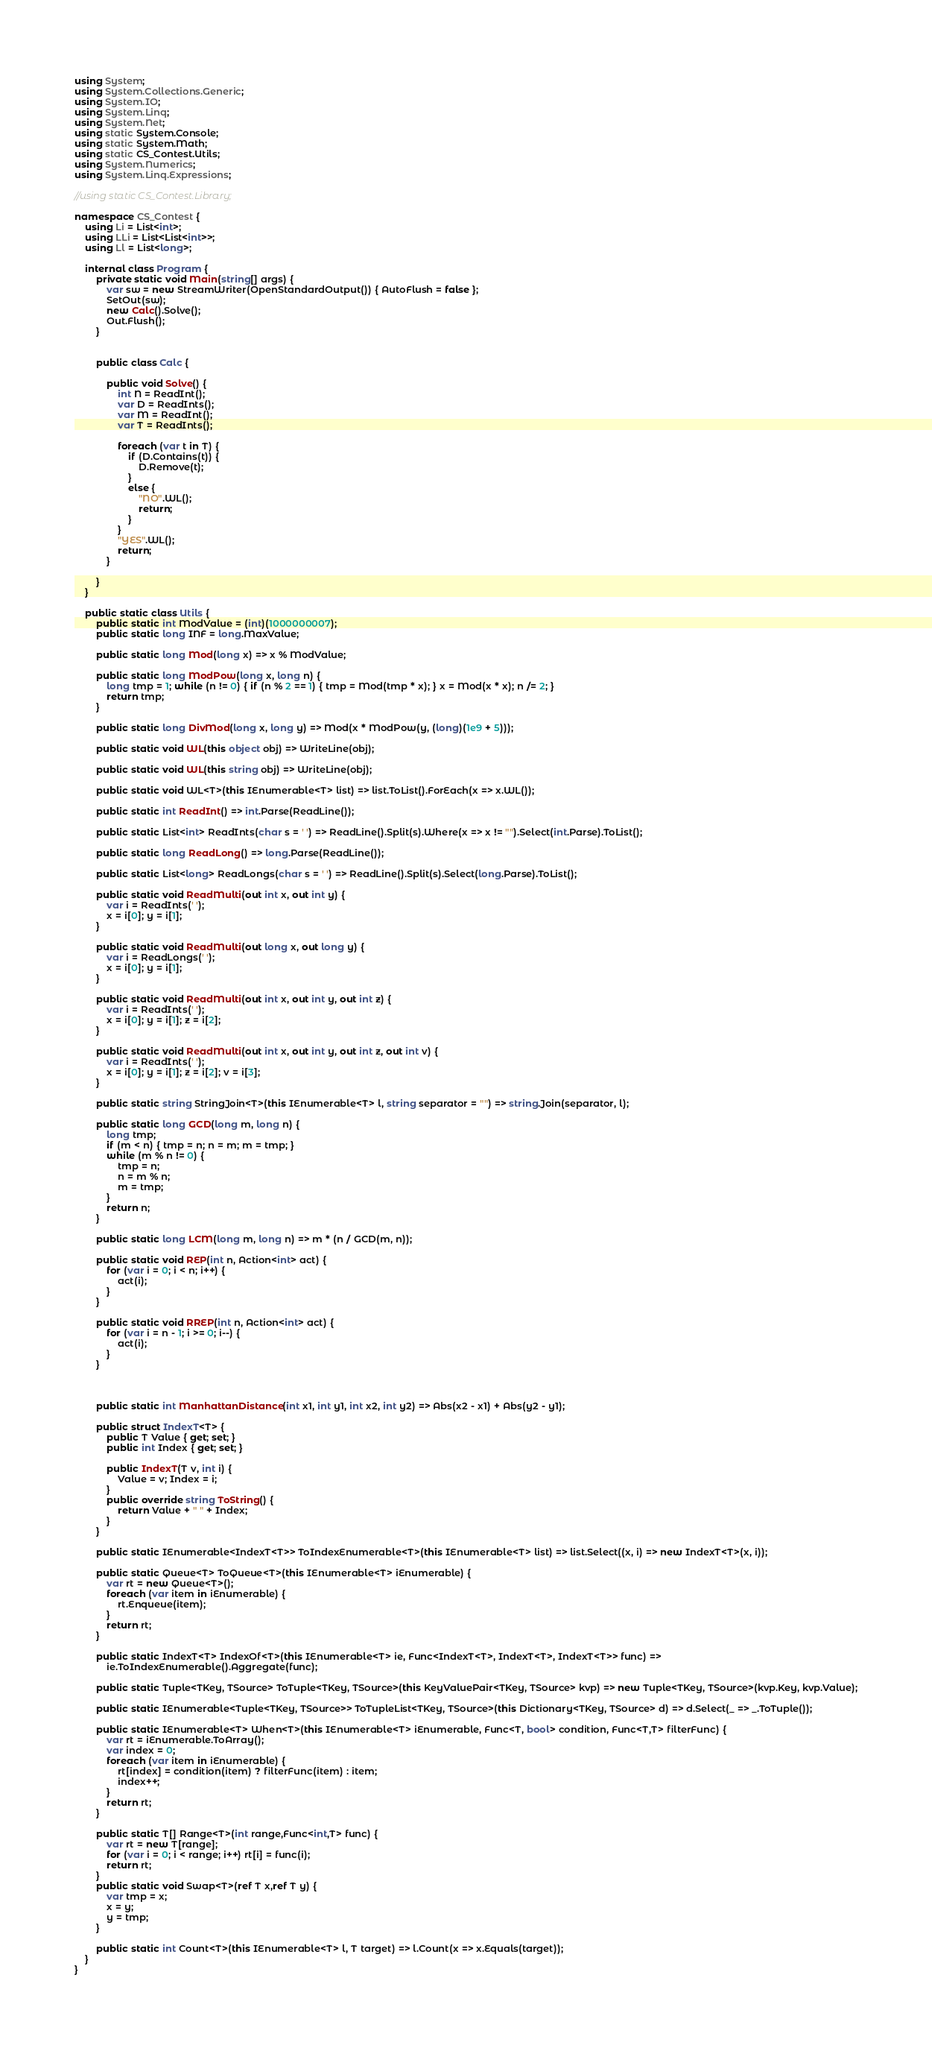<code> <loc_0><loc_0><loc_500><loc_500><_C#_>using System;
using System.Collections.Generic;
using System.IO;
using System.Linq;
using System.Net;
using static System.Console;
using static System.Math;
using static CS_Contest.Utils;
using System.Numerics;
using System.Linq.Expressions;

//using static CS_Contest.Library;

namespace CS_Contest {
	using Li = List<int>;
	using LLi = List<List<int>>;
	using Ll = List<long>;

	internal class Program {
		private static void Main(string[] args) {
			var sw = new StreamWriter(OpenStandardOutput()) { AutoFlush = false };
			SetOut(sw);
			new Calc().Solve();
			Out.Flush();
		}
		

		public class Calc {

			public void Solve() {
				int N = ReadInt();
				var D = ReadInts();
				var M = ReadInt();
				var T = ReadInts();

				foreach (var t in T) {
					if (D.Contains(t)) {
						D.Remove(t);
					}
					else {
						"NO".WL();
						return;
					}
				}
				"YES".WL();
				return;
			}

		}
	}

	public static class Utils {
		public static int ModValue = (int)(1000000007);
		public static long INF = long.MaxValue;

		public static long Mod(long x) => x % ModValue;

		public static long ModPow(long x, long n) {
			long tmp = 1; while (n != 0) { if (n % 2 == 1) { tmp = Mod(tmp * x); } x = Mod(x * x); n /= 2; }
			return tmp;
		}

		public static long DivMod(long x, long y) => Mod(x * ModPow(y, (long)(1e9 + 5)));

		public static void WL(this object obj) => WriteLine(obj);

		public static void WL(this string obj) => WriteLine(obj);

		public static void WL<T>(this IEnumerable<T> list) => list.ToList().ForEach(x => x.WL());

		public static int ReadInt() => int.Parse(ReadLine());

		public static List<int> ReadInts(char s = ' ') => ReadLine().Split(s).Where(x => x != "").Select(int.Parse).ToList();

		public static long ReadLong() => long.Parse(ReadLine());

		public static List<long> ReadLongs(char s = ' ') => ReadLine().Split(s).Select(long.Parse).ToList();

		public static void ReadMulti(out int x, out int y) {
			var i = ReadInts(' ');
			x = i[0]; y = i[1];
		}

		public static void ReadMulti(out long x, out long y) {
			var i = ReadLongs(' ');
			x = i[0]; y = i[1];
		}

		public static void ReadMulti(out int x, out int y, out int z) {
			var i = ReadInts(' ');
			x = i[0]; y = i[1]; z = i[2];
		}

		public static void ReadMulti(out int x, out int y, out int z, out int v) {
			var i = ReadInts(' ');
			x = i[0]; y = i[1]; z = i[2]; v = i[3];
		}

		public static string StringJoin<T>(this IEnumerable<T> l, string separator = "") => string.Join(separator, l);

		public static long GCD(long m, long n) {
			long tmp;
			if (m < n) { tmp = n; n = m; m = tmp; }
			while (m % n != 0) {
				tmp = n;
				n = m % n;
				m = tmp;
			}
			return n;
		}

		public static long LCM(long m, long n) => m * (n / GCD(m, n));

		public static void REP(int n, Action<int> act) {
			for (var i = 0; i < n; i++) {
				act(i);
			}
		}

		public static void RREP(int n, Action<int> act) {
			for (var i = n - 1; i >= 0; i--) {
				act(i);
			}
		}



		public static int ManhattanDistance(int x1, int y1, int x2, int y2) => Abs(x2 - x1) + Abs(y2 - y1);

		public struct IndexT<T> {
			public T Value { get; set; }
			public int Index { get; set; }

			public IndexT(T v, int i) {
				Value = v; Index = i;
			}
			public override string ToString() {
				return Value + " " + Index;
			}
		}

		public static IEnumerable<IndexT<T>> ToIndexEnumerable<T>(this IEnumerable<T> list) => list.Select((x, i) => new IndexT<T>(x, i));

		public static Queue<T> ToQueue<T>(this IEnumerable<T> iEnumerable) {
			var rt = new Queue<T>();
			foreach (var item in iEnumerable) {
				rt.Enqueue(item);
			}
			return rt;
		}

		public static IndexT<T> IndexOf<T>(this IEnumerable<T> ie, Func<IndexT<T>, IndexT<T>, IndexT<T>> func) =>
			ie.ToIndexEnumerable().Aggregate(func);

		public static Tuple<TKey, TSource> ToTuple<TKey, TSource>(this KeyValuePair<TKey, TSource> kvp) => new Tuple<TKey, TSource>(kvp.Key, kvp.Value);

		public static IEnumerable<Tuple<TKey, TSource>> ToTupleList<TKey, TSource>(this Dictionary<TKey, TSource> d) => d.Select(_ => _.ToTuple());

		public static IEnumerable<T> When<T>(this IEnumerable<T> iEnumerable, Func<T, bool> condition, Func<T,T> filterFunc) {
			var rt = iEnumerable.ToArray();
			var index = 0;
			foreach (var item in iEnumerable) {
				rt[index] = condition(item) ? filterFunc(item) : item;
				index++;
			}
			return rt;
		}

		public static T[] Range<T>(int range,Func<int,T> func) {
			var rt = new T[range];
			for (var i = 0; i < range; i++) rt[i] = func(i);
			return rt;
		}
		public static void Swap<T>(ref T x,ref T y) {
			var tmp = x;
			x = y;
			y = tmp;
		}

		public static int Count<T>(this IEnumerable<T> l, T target) => l.Count(x => x.Equals(target));
	}
}</code> 